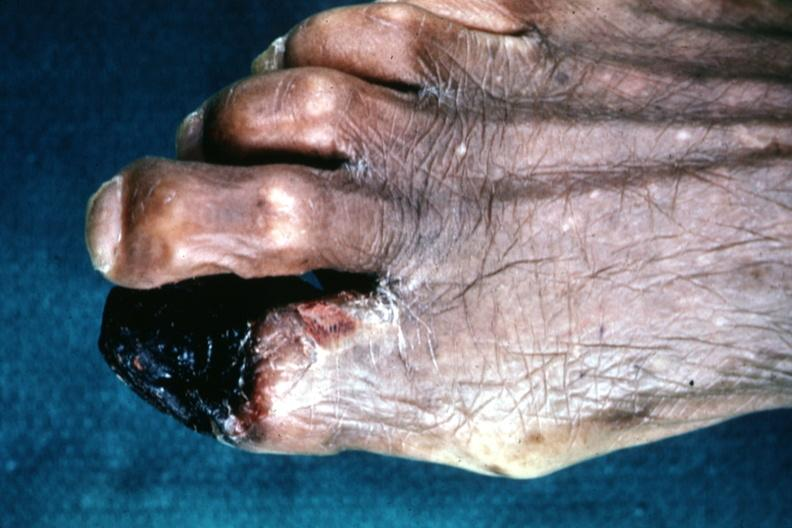what does this image show?
Answer the question using a single word or phrase. Excellent great toe lesion 